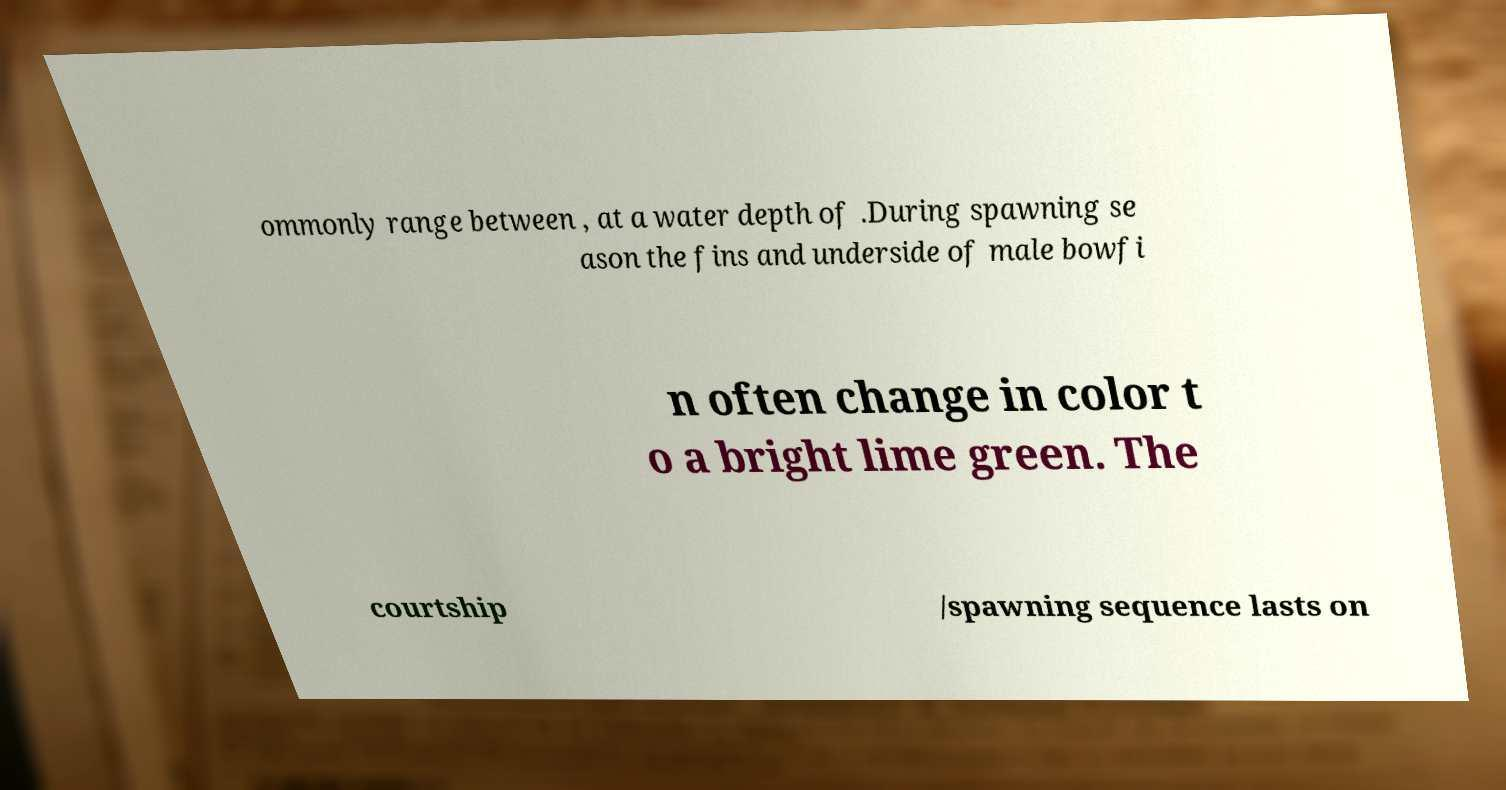Could you assist in decoding the text presented in this image and type it out clearly? ommonly range between , at a water depth of .During spawning se ason the fins and underside of male bowfi n often change in color t o a bright lime green. The courtship /spawning sequence lasts on 